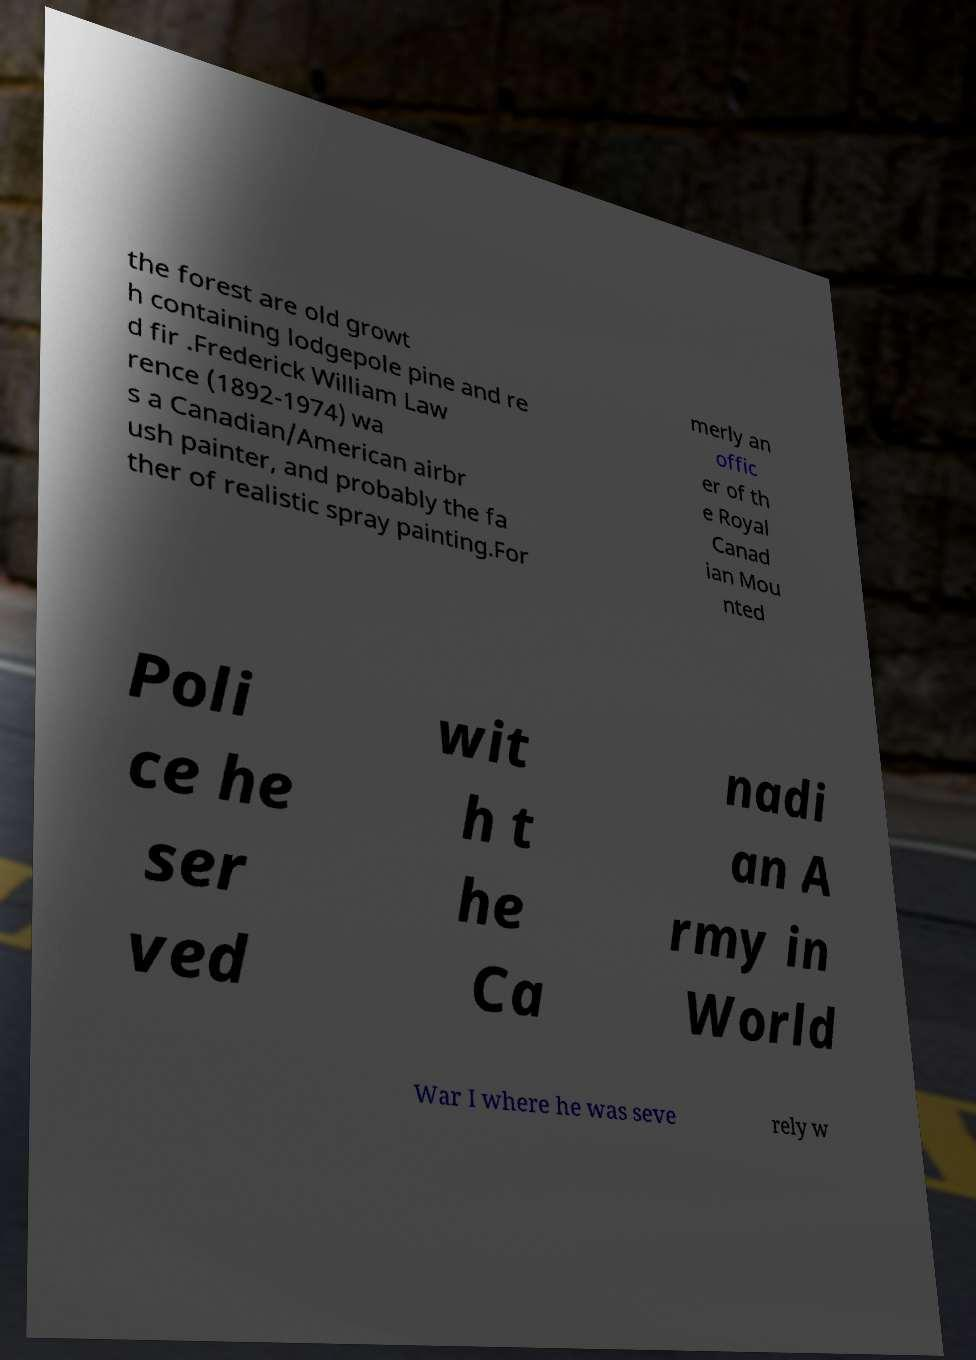There's text embedded in this image that I need extracted. Can you transcribe it verbatim? the forest are old growt h containing lodgepole pine and re d fir .Frederick William Law rence (1892-1974) wa s a Canadian/American airbr ush painter, and probably the fa ther of realistic spray painting.For merly an offic er of th e Royal Canad ian Mou nted Poli ce he ser ved wit h t he Ca nadi an A rmy in World War I where he was seve rely w 